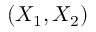<formula> <loc_0><loc_0><loc_500><loc_500>( X _ { 1 } , X _ { 2 } )</formula> 